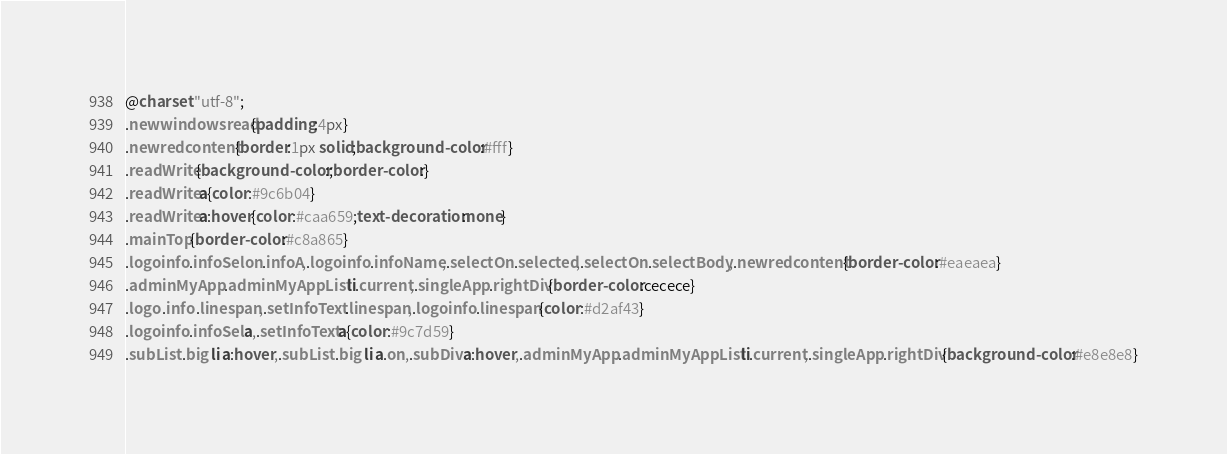<code> <loc_0><loc_0><loc_500><loc_500><_CSS_>@charset "utf-8";
.newwindowsread{padding:4px}
.newredcontent{border:1px solid;background-color:#fff}
.readWrite{background-color:;border-color:}
.readWrite a{color:#9c6b04}
.readWrite a:hover{color:#caa659;text-decoration:none}
.mainTop{border-color:#c8a865}
.logoinfo .infoSelon .infoA,.logoinfo .infoName,.selectOn .selected,.selectOn .selectBody,.newredcontent{border-color:#eaeaea}
.adminMyApp .adminMyAppList li.current,.singleApp .rightDiv{border-color:cecece}
.logo .info .linespan,.setInfoText .linespan,.logoinfo .linespan{color:#d2af43}
.logoinfo .infoSel a,.setInfoText a{color:#9c7d59}
.subList .big li a:hover,.subList .big li a.on,.subDiv a:hover,.adminMyApp .adminMyAppList li.current,.singleApp .rightDiv{background-color:#e8e8e8}</code> 